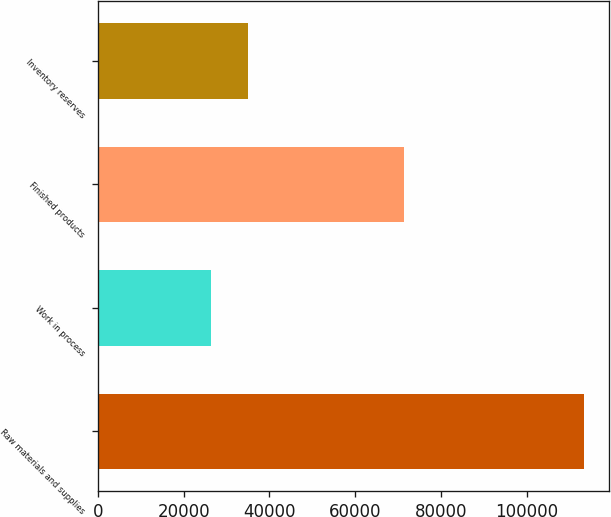Convert chart to OTSL. <chart><loc_0><loc_0><loc_500><loc_500><bar_chart><fcel>Raw materials and supplies<fcel>Work in process<fcel>Finished products<fcel>Inventory reserves<nl><fcel>113415<fcel>26358<fcel>71302<fcel>35063.7<nl></chart> 